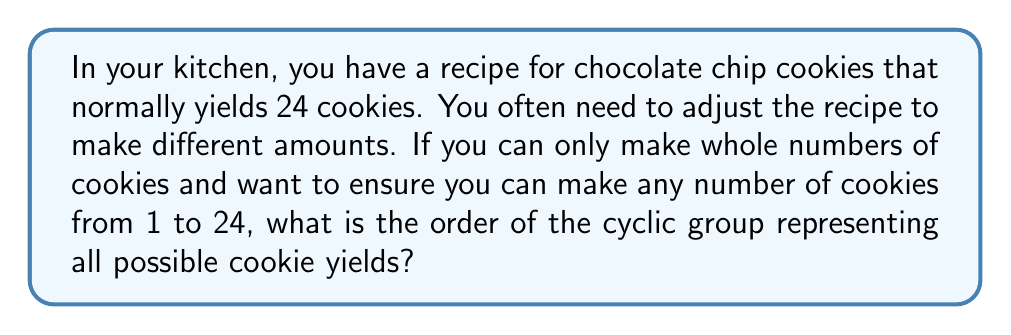Teach me how to tackle this problem. Let's approach this step-by-step:

1) In group theory, a cyclic group is a group that can be generated by a single element. In this case, our generator would be the number of cookies in one batch (24).

2) The possible yields form a cyclic group under the operation of addition modulo 24. This is because making multiple batches is equivalent to adding 24 repeatedly.

3) The order of a cyclic group is the smallest positive integer $n$ such that $g^n = e$, where $g$ is the generator and $e$ is the identity element.

4) In our case, we're looking for the smallest positive integer $n$ such that:

   $24n \equiv 0 \pmod{24}$

5) This is equivalent to finding the least common multiple (LCM) of 24 and the desired range (1 to 24).

6) The LCM of 24 and any number from 1 to 24 is 24 itself, because 24 is divisible by all these numbers.

Therefore, the order of the cyclic group is 24.

This means you can make any number of cookies from 1 to 24 by appropriately scaling your recipe. For example:
- 1 cookie: $24 \cdot \frac{1}{24} \equiv 1 \pmod{24}$
- 12 cookies: $24 \cdot \frac{1}{2} \equiv 12 \pmod{24}$
- 24 cookies: $24 \cdot 1 \equiv 0 \pmod{24}$ (which is equivalent to 24 in this context)
Answer: The order of the cyclic group representing all possible cookie yields is 24. 